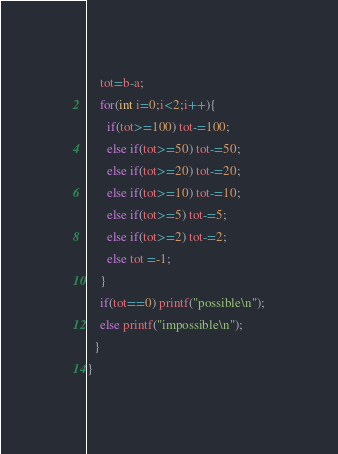<code> <loc_0><loc_0><loc_500><loc_500><_C++_>    tot=b-a;
    for(int i=0;i<2;i++){
      if(tot>=100) tot-=100;
      else if(tot>=50) tot-=50;
      else if(tot>=20) tot-=20;
      else if(tot>=10) tot-=10;
      else if(tot>=5) tot-=5;
      else if(tot>=2) tot-=2;
      else tot =-1;
    }
    if(tot==0) printf("possible\n");
    else printf("impossible\n");
  }
}</code> 